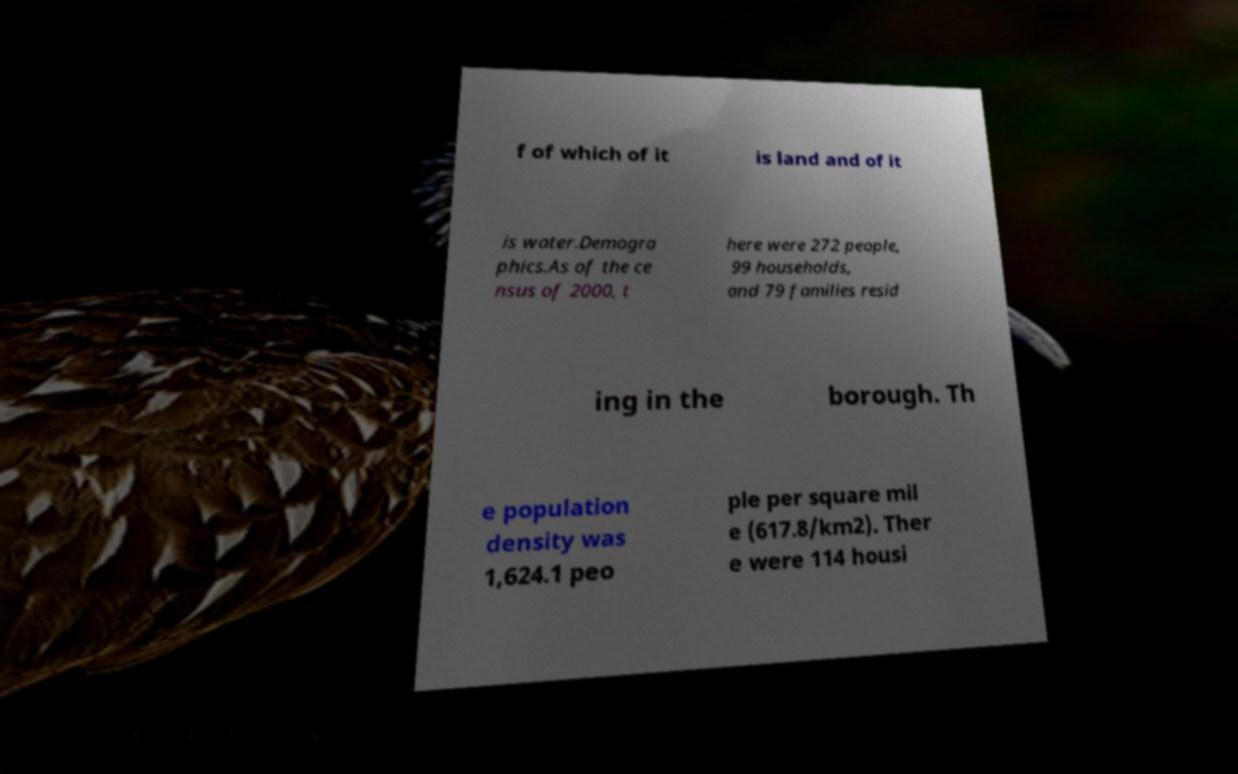What messages or text are displayed in this image? I need them in a readable, typed format. f of which of it is land and of it is water.Demogra phics.As of the ce nsus of 2000, t here were 272 people, 99 households, and 79 families resid ing in the borough. Th e population density was 1,624.1 peo ple per square mil e (617.8/km2). Ther e were 114 housi 